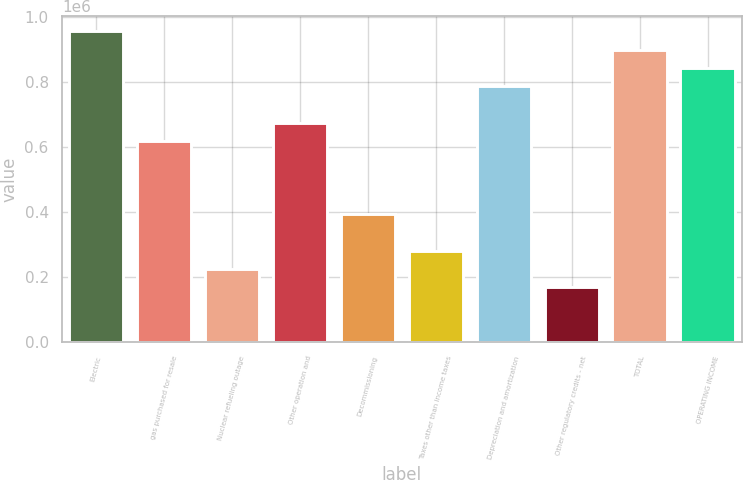Convert chart to OTSL. <chart><loc_0><loc_0><loc_500><loc_500><bar_chart><fcel>Electric<fcel>gas purchased for resale<fcel>Nuclear refueling outage<fcel>Other operation and<fcel>Decommissioning<fcel>Taxes other than income taxes<fcel>Depreciation and amortization<fcel>Other regulatory credits - net<fcel>TOTAL<fcel>OPERATING INCOME<nl><fcel>957309<fcel>619682<fcel>225784<fcel>675953<fcel>394597<fcel>282055<fcel>788496<fcel>169513<fcel>901038<fcel>844767<nl></chart> 